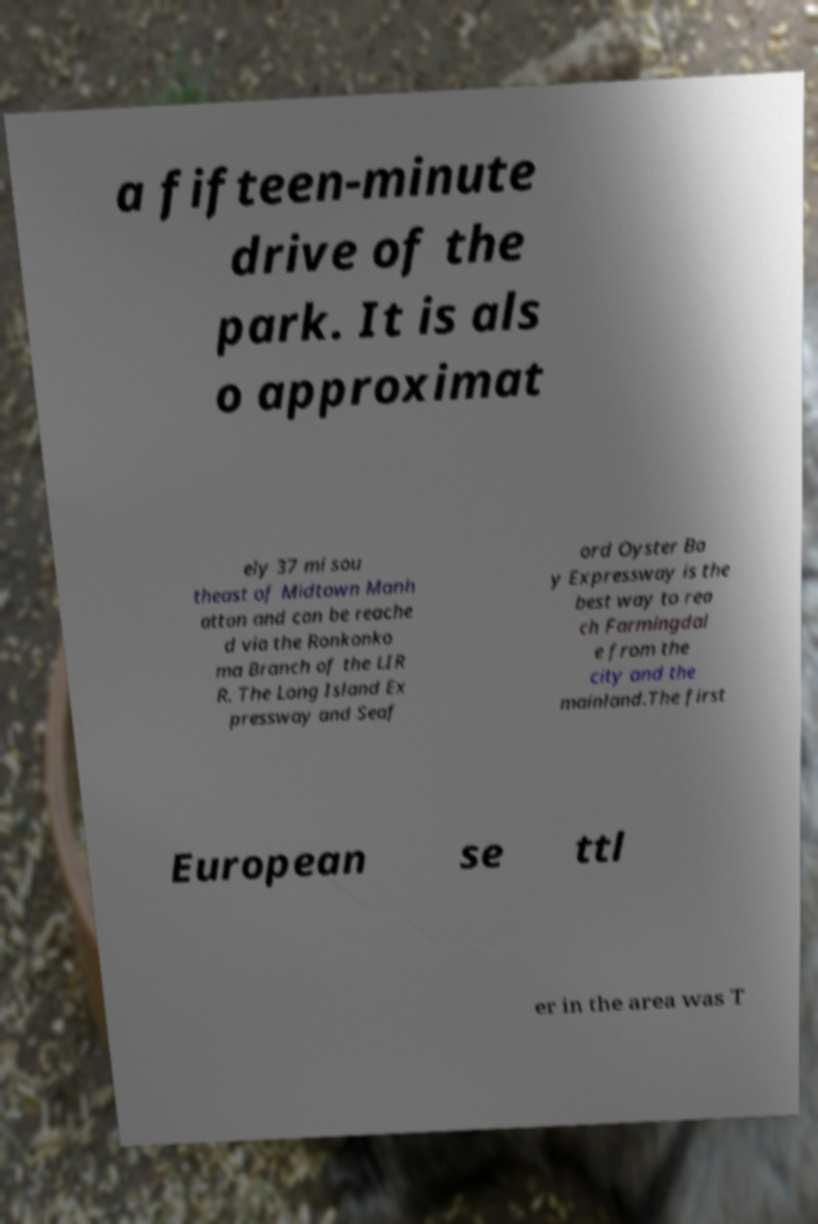What messages or text are displayed in this image? I need them in a readable, typed format. a fifteen-minute drive of the park. It is als o approximat ely 37 mi sou theast of Midtown Manh attan and can be reache d via the Ronkonko ma Branch of the LIR R. The Long Island Ex pressway and Seaf ord Oyster Ba y Expressway is the best way to rea ch Farmingdal e from the city and the mainland.The first European se ttl er in the area was T 